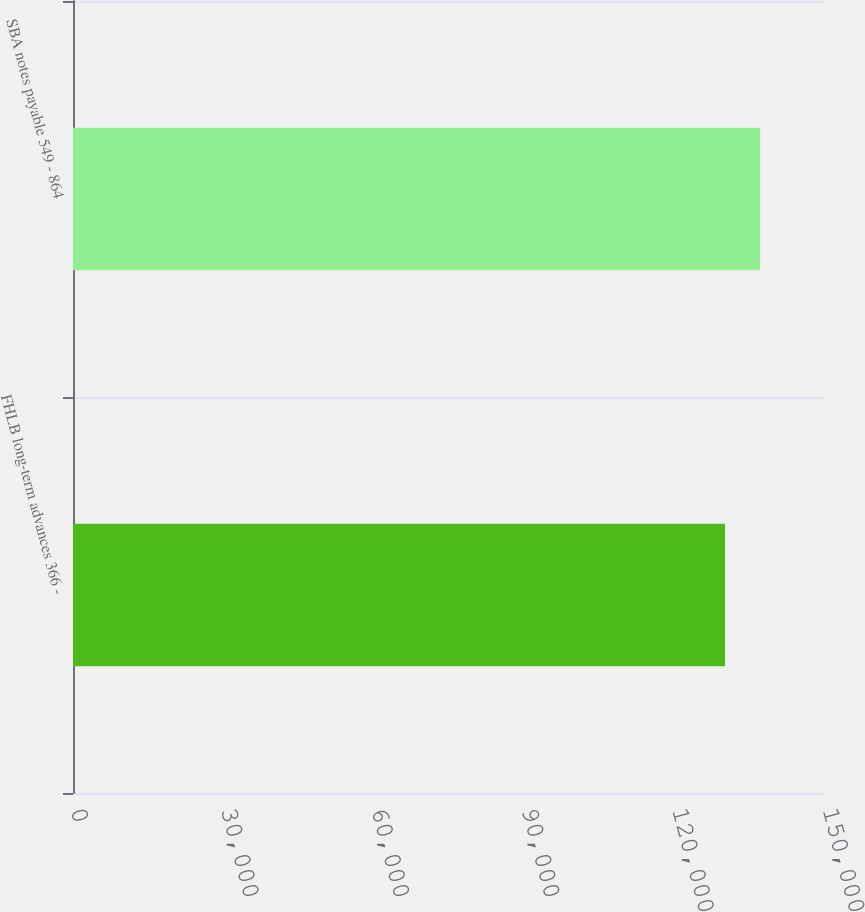Convert chart to OTSL. <chart><loc_0><loc_0><loc_500><loc_500><bar_chart><fcel>FHLB long-term advances 366 -<fcel>SBA notes payable 549 - 864<nl><fcel>130058<fcel>137058<nl></chart> 